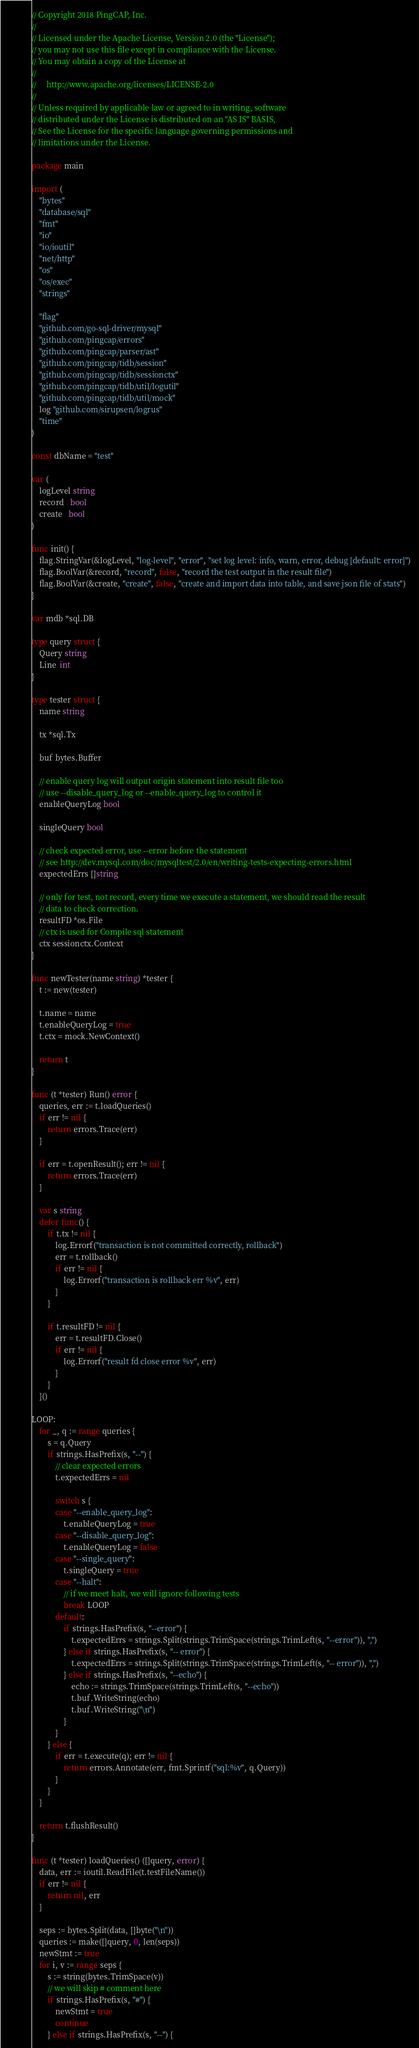Convert code to text. <code><loc_0><loc_0><loc_500><loc_500><_Go_>// Copyright 2018 PingCAP, Inc.
//
// Licensed under the Apache License, Version 2.0 (the "License");
// you may not use this file except in compliance with the License.
// You may obtain a copy of the License at
//
//     http://www.apache.org/licenses/LICENSE-2.0
//
// Unless required by applicable law or agreed to in writing, software
// distributed under the License is distributed on an "AS IS" BASIS,
// See the License for the specific language governing permissions and
// limitations under the License.

package main

import (
	"bytes"
	"database/sql"
	"fmt"
	"io"
	"io/ioutil"
	"net/http"
	"os"
	"os/exec"
	"strings"

	"flag"
	"github.com/go-sql-driver/mysql"
	"github.com/pingcap/errors"
	"github.com/pingcap/parser/ast"
	"github.com/pingcap/tidb/session"
	"github.com/pingcap/tidb/sessionctx"
	"github.com/pingcap/tidb/util/logutil"
	"github.com/pingcap/tidb/util/mock"
	log "github.com/sirupsen/logrus"
	"time"
)

const dbName = "test"

var (
	logLevel string
	record   bool
	create   bool
)

func init() {
	flag.StringVar(&logLevel, "log-level", "error", "set log level: info, warn, error, debug [default: error]")
	flag.BoolVar(&record, "record", false, "record the test output in the result file")
	flag.BoolVar(&create, "create", false, "create and import data into table, and save json file of stats")
}

var mdb *sql.DB

type query struct {
	Query string
	Line  int
}

type tester struct {
	name string

	tx *sql.Tx

	buf bytes.Buffer

	// enable query log will output origin statement into result file too
	// use --disable_query_log or --enable_query_log to control it
	enableQueryLog bool

	singleQuery bool

	// check expected error, use --error before the statement
	// see http://dev.mysql.com/doc/mysqltest/2.0/en/writing-tests-expecting-errors.html
	expectedErrs []string

	// only for test, not record, every time we execute a statement, we should read the result
	// data to check correction.
	resultFD *os.File
	// ctx is used for Compile sql statement
	ctx sessionctx.Context
}

func newTester(name string) *tester {
	t := new(tester)

	t.name = name
	t.enableQueryLog = true
	t.ctx = mock.NewContext()

	return t
}

func (t *tester) Run() error {
	queries, err := t.loadQueries()
	if err != nil {
		return errors.Trace(err)
	}

	if err = t.openResult(); err != nil {
		return errors.Trace(err)
	}

	var s string
	defer func() {
		if t.tx != nil {
			log.Errorf("transaction is not committed correctly, rollback")
			err = t.rollback()
			if err != nil {
				log.Errorf("transaction is rollback err %v", err)
			}
		}

		if t.resultFD != nil {
			err = t.resultFD.Close()
			if err != nil {
				log.Errorf("result fd close error %v", err)
			}
		}
	}()

LOOP:
	for _, q := range queries {
		s = q.Query
		if strings.HasPrefix(s, "--") {
			// clear expected errors
			t.expectedErrs = nil

			switch s {
			case "--enable_query_log":
				t.enableQueryLog = true
			case "--disable_query_log":
				t.enableQueryLog = false
			case "--single_query":
				t.singleQuery = true
			case "--halt":
				// if we meet halt, we will ignore following tests
				break LOOP
			default:
				if strings.HasPrefix(s, "--error") {
					t.expectedErrs = strings.Split(strings.TrimSpace(strings.TrimLeft(s, "--error")), ",")
				} else if strings.HasPrefix(s, "-- error") {
					t.expectedErrs = strings.Split(strings.TrimSpace(strings.TrimLeft(s, "-- error")), ",")
				} else if strings.HasPrefix(s, "--echo") {
					echo := strings.TrimSpace(strings.TrimLeft(s, "--echo"))
					t.buf.WriteString(echo)
					t.buf.WriteString("\n")
				}
			}
		} else {
			if err = t.execute(q); err != nil {
				return errors.Annotate(err, fmt.Sprintf("sql:%v", q.Query))
			}
		}
	}

	return t.flushResult()
}

func (t *tester) loadQueries() ([]query, error) {
	data, err := ioutil.ReadFile(t.testFileName())
	if err != nil {
		return nil, err
	}

	seps := bytes.Split(data, []byte("\n"))
	queries := make([]query, 0, len(seps))
	newStmt := true
	for i, v := range seps {
		s := string(bytes.TrimSpace(v))
		// we will skip # comment here
		if strings.HasPrefix(s, "#") {
			newStmt = true
			continue
		} else if strings.HasPrefix(s, "--") {</code> 